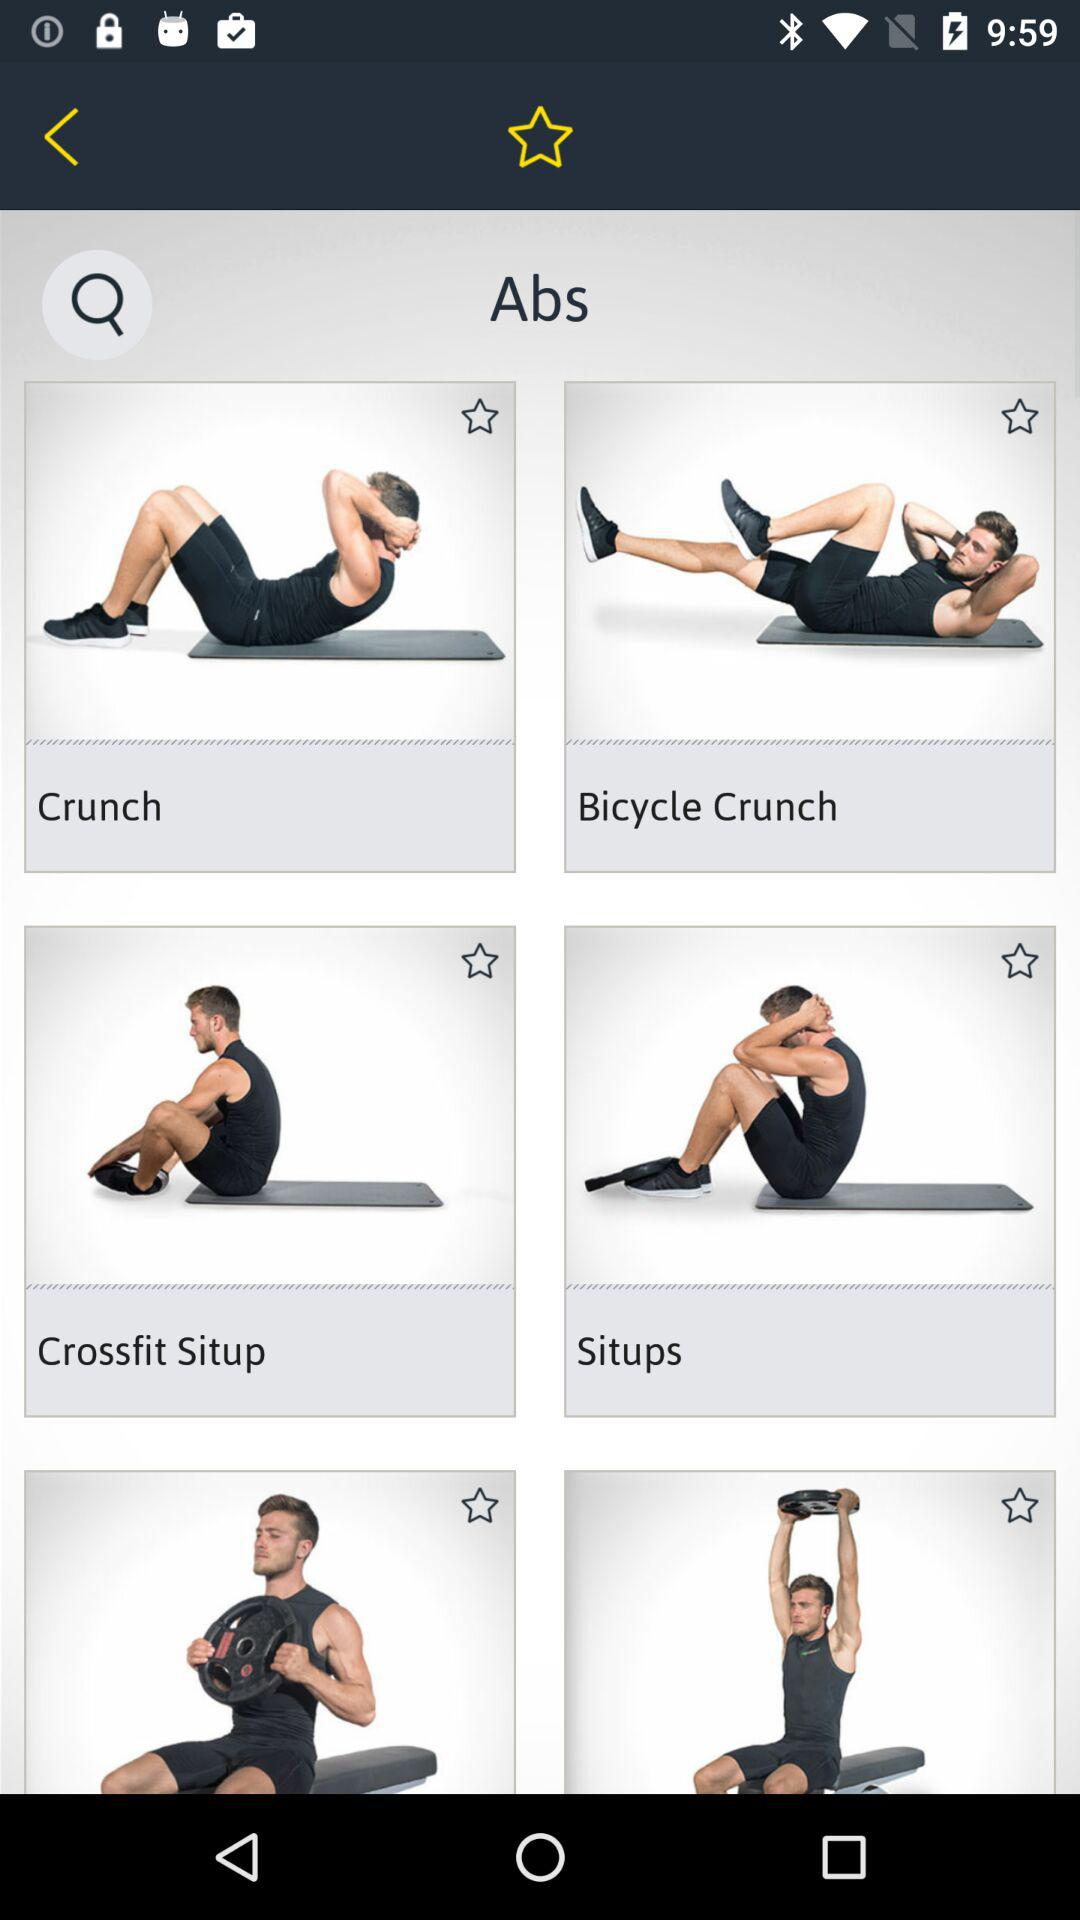What are the different abs exercises there are? The different abs exercises are "Crunch", "Bicycle Crunch", "Crossfit Situp" and "Situps". 